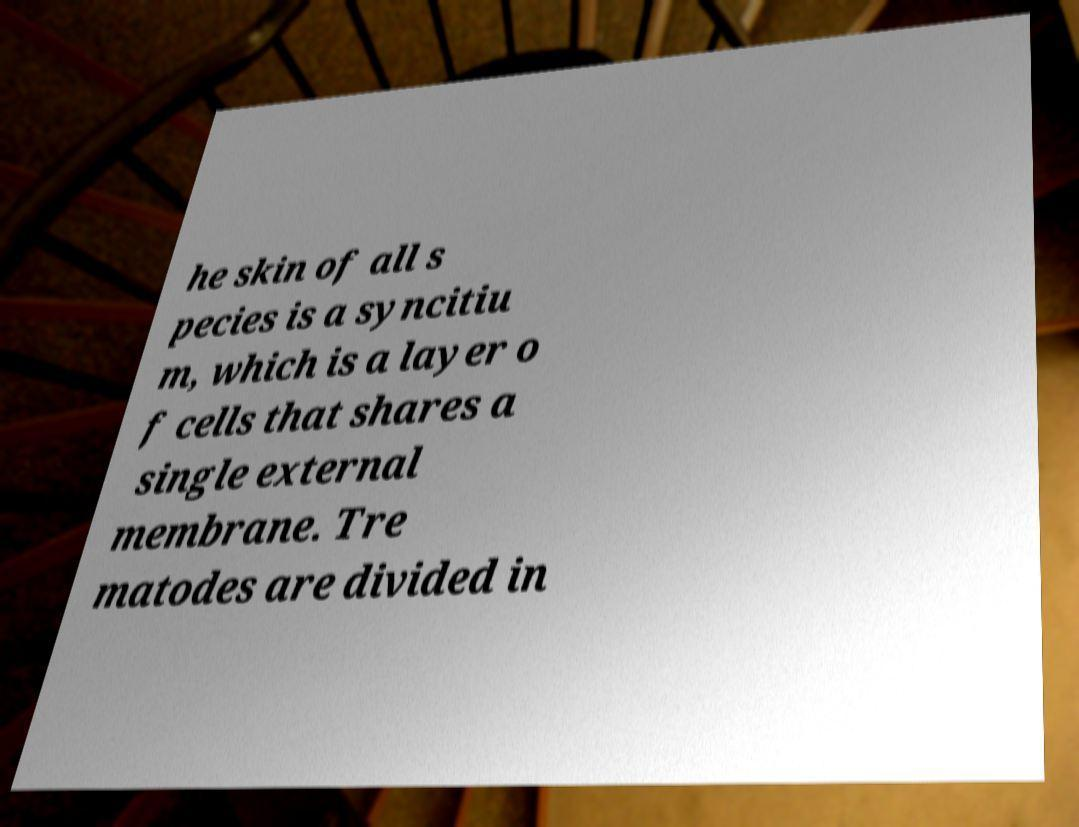Can you read and provide the text displayed in the image?This photo seems to have some interesting text. Can you extract and type it out for me? he skin of all s pecies is a syncitiu m, which is a layer o f cells that shares a single external membrane. Tre matodes are divided in 